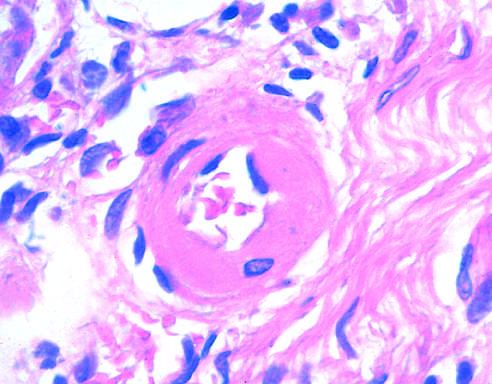s the lumen markedly narrowed?
Answer the question using a single word or phrase. Yes 